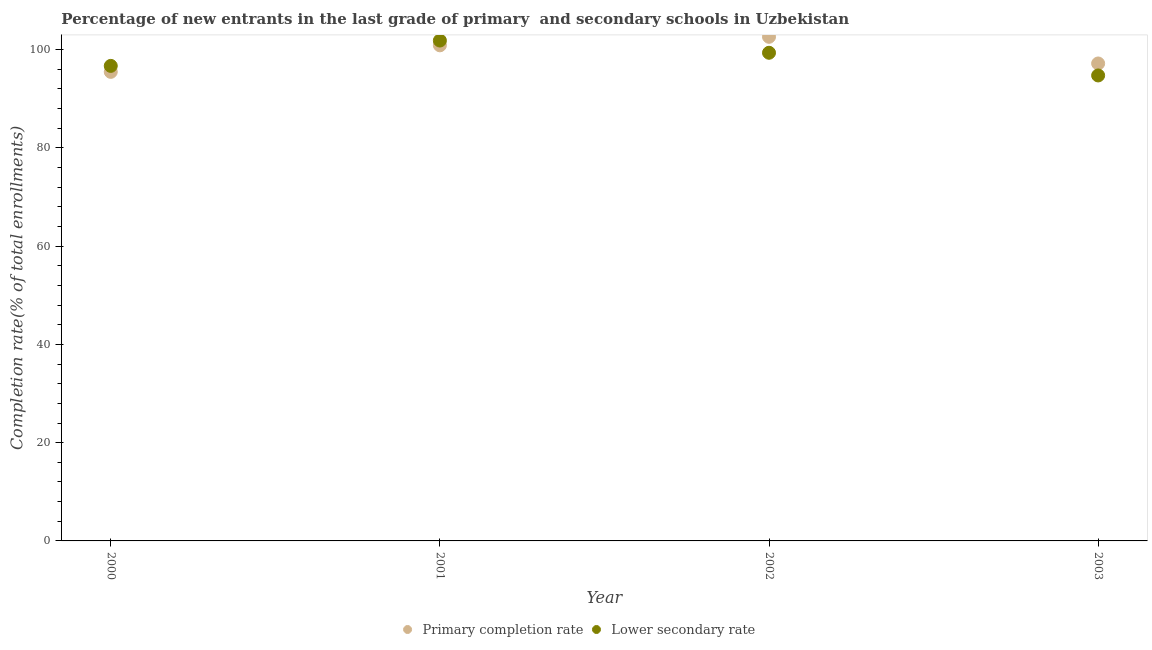What is the completion rate in primary schools in 2002?
Offer a very short reply. 102.61. Across all years, what is the maximum completion rate in secondary schools?
Ensure brevity in your answer.  101.84. Across all years, what is the minimum completion rate in secondary schools?
Provide a succinct answer. 94.74. What is the total completion rate in secondary schools in the graph?
Ensure brevity in your answer.  392.63. What is the difference between the completion rate in secondary schools in 2002 and that in 2003?
Keep it short and to the point. 4.61. What is the difference between the completion rate in secondary schools in 2003 and the completion rate in primary schools in 2001?
Keep it short and to the point. -6.13. What is the average completion rate in secondary schools per year?
Your response must be concise. 98.16. In the year 2003, what is the difference between the completion rate in secondary schools and completion rate in primary schools?
Ensure brevity in your answer.  -2.44. In how many years, is the completion rate in primary schools greater than 16 %?
Ensure brevity in your answer.  4. What is the ratio of the completion rate in secondary schools in 2001 to that in 2002?
Offer a very short reply. 1.03. What is the difference between the highest and the second highest completion rate in secondary schools?
Provide a short and direct response. 2.49. What is the difference between the highest and the lowest completion rate in secondary schools?
Ensure brevity in your answer.  7.1. In how many years, is the completion rate in primary schools greater than the average completion rate in primary schools taken over all years?
Ensure brevity in your answer.  2. Is the sum of the completion rate in primary schools in 2001 and 2003 greater than the maximum completion rate in secondary schools across all years?
Offer a very short reply. Yes. How many dotlines are there?
Your response must be concise. 2. What is the title of the graph?
Make the answer very short. Percentage of new entrants in the last grade of primary  and secondary schools in Uzbekistan. What is the label or title of the X-axis?
Your response must be concise. Year. What is the label or title of the Y-axis?
Your answer should be very brief. Completion rate(% of total enrollments). What is the Completion rate(% of total enrollments) of Primary completion rate in 2000?
Keep it short and to the point. 95.47. What is the Completion rate(% of total enrollments) of Lower secondary rate in 2000?
Offer a terse response. 96.69. What is the Completion rate(% of total enrollments) in Primary completion rate in 2001?
Your answer should be compact. 100.87. What is the Completion rate(% of total enrollments) in Lower secondary rate in 2001?
Keep it short and to the point. 101.84. What is the Completion rate(% of total enrollments) of Primary completion rate in 2002?
Provide a succinct answer. 102.61. What is the Completion rate(% of total enrollments) of Lower secondary rate in 2002?
Ensure brevity in your answer.  99.36. What is the Completion rate(% of total enrollments) of Primary completion rate in 2003?
Provide a succinct answer. 97.18. What is the Completion rate(% of total enrollments) in Lower secondary rate in 2003?
Keep it short and to the point. 94.74. Across all years, what is the maximum Completion rate(% of total enrollments) in Primary completion rate?
Provide a short and direct response. 102.61. Across all years, what is the maximum Completion rate(% of total enrollments) of Lower secondary rate?
Your answer should be very brief. 101.84. Across all years, what is the minimum Completion rate(% of total enrollments) in Primary completion rate?
Your response must be concise. 95.47. Across all years, what is the minimum Completion rate(% of total enrollments) of Lower secondary rate?
Keep it short and to the point. 94.74. What is the total Completion rate(% of total enrollments) of Primary completion rate in the graph?
Make the answer very short. 396.13. What is the total Completion rate(% of total enrollments) in Lower secondary rate in the graph?
Give a very brief answer. 392.63. What is the difference between the Completion rate(% of total enrollments) of Primary completion rate in 2000 and that in 2001?
Keep it short and to the point. -5.4. What is the difference between the Completion rate(% of total enrollments) in Lower secondary rate in 2000 and that in 2001?
Give a very brief answer. -5.16. What is the difference between the Completion rate(% of total enrollments) in Primary completion rate in 2000 and that in 2002?
Ensure brevity in your answer.  -7.14. What is the difference between the Completion rate(% of total enrollments) of Lower secondary rate in 2000 and that in 2002?
Give a very brief answer. -2.67. What is the difference between the Completion rate(% of total enrollments) of Primary completion rate in 2000 and that in 2003?
Ensure brevity in your answer.  -1.71. What is the difference between the Completion rate(% of total enrollments) of Lower secondary rate in 2000 and that in 2003?
Your response must be concise. 1.95. What is the difference between the Completion rate(% of total enrollments) in Primary completion rate in 2001 and that in 2002?
Ensure brevity in your answer.  -1.73. What is the difference between the Completion rate(% of total enrollments) of Lower secondary rate in 2001 and that in 2002?
Your answer should be very brief. 2.49. What is the difference between the Completion rate(% of total enrollments) of Primary completion rate in 2001 and that in 2003?
Ensure brevity in your answer.  3.69. What is the difference between the Completion rate(% of total enrollments) of Lower secondary rate in 2001 and that in 2003?
Your answer should be very brief. 7.1. What is the difference between the Completion rate(% of total enrollments) of Primary completion rate in 2002 and that in 2003?
Make the answer very short. 5.43. What is the difference between the Completion rate(% of total enrollments) of Lower secondary rate in 2002 and that in 2003?
Your answer should be compact. 4.61. What is the difference between the Completion rate(% of total enrollments) in Primary completion rate in 2000 and the Completion rate(% of total enrollments) in Lower secondary rate in 2001?
Ensure brevity in your answer.  -6.37. What is the difference between the Completion rate(% of total enrollments) in Primary completion rate in 2000 and the Completion rate(% of total enrollments) in Lower secondary rate in 2002?
Your answer should be compact. -3.89. What is the difference between the Completion rate(% of total enrollments) in Primary completion rate in 2000 and the Completion rate(% of total enrollments) in Lower secondary rate in 2003?
Provide a short and direct response. 0.73. What is the difference between the Completion rate(% of total enrollments) of Primary completion rate in 2001 and the Completion rate(% of total enrollments) of Lower secondary rate in 2002?
Ensure brevity in your answer.  1.52. What is the difference between the Completion rate(% of total enrollments) in Primary completion rate in 2001 and the Completion rate(% of total enrollments) in Lower secondary rate in 2003?
Provide a short and direct response. 6.13. What is the difference between the Completion rate(% of total enrollments) of Primary completion rate in 2002 and the Completion rate(% of total enrollments) of Lower secondary rate in 2003?
Offer a terse response. 7.86. What is the average Completion rate(% of total enrollments) in Primary completion rate per year?
Your response must be concise. 99.03. What is the average Completion rate(% of total enrollments) in Lower secondary rate per year?
Ensure brevity in your answer.  98.16. In the year 2000, what is the difference between the Completion rate(% of total enrollments) of Primary completion rate and Completion rate(% of total enrollments) of Lower secondary rate?
Provide a short and direct response. -1.22. In the year 2001, what is the difference between the Completion rate(% of total enrollments) in Primary completion rate and Completion rate(% of total enrollments) in Lower secondary rate?
Provide a short and direct response. -0.97. In the year 2002, what is the difference between the Completion rate(% of total enrollments) in Primary completion rate and Completion rate(% of total enrollments) in Lower secondary rate?
Make the answer very short. 3.25. In the year 2003, what is the difference between the Completion rate(% of total enrollments) of Primary completion rate and Completion rate(% of total enrollments) of Lower secondary rate?
Keep it short and to the point. 2.44. What is the ratio of the Completion rate(% of total enrollments) in Primary completion rate in 2000 to that in 2001?
Provide a short and direct response. 0.95. What is the ratio of the Completion rate(% of total enrollments) in Lower secondary rate in 2000 to that in 2001?
Keep it short and to the point. 0.95. What is the ratio of the Completion rate(% of total enrollments) in Primary completion rate in 2000 to that in 2002?
Make the answer very short. 0.93. What is the ratio of the Completion rate(% of total enrollments) in Lower secondary rate in 2000 to that in 2002?
Offer a very short reply. 0.97. What is the ratio of the Completion rate(% of total enrollments) of Primary completion rate in 2000 to that in 2003?
Your answer should be very brief. 0.98. What is the ratio of the Completion rate(% of total enrollments) in Lower secondary rate in 2000 to that in 2003?
Keep it short and to the point. 1.02. What is the ratio of the Completion rate(% of total enrollments) in Primary completion rate in 2001 to that in 2002?
Your answer should be very brief. 0.98. What is the ratio of the Completion rate(% of total enrollments) of Lower secondary rate in 2001 to that in 2002?
Your answer should be very brief. 1.02. What is the ratio of the Completion rate(% of total enrollments) of Primary completion rate in 2001 to that in 2003?
Keep it short and to the point. 1.04. What is the ratio of the Completion rate(% of total enrollments) in Lower secondary rate in 2001 to that in 2003?
Your response must be concise. 1.07. What is the ratio of the Completion rate(% of total enrollments) of Primary completion rate in 2002 to that in 2003?
Give a very brief answer. 1.06. What is the ratio of the Completion rate(% of total enrollments) in Lower secondary rate in 2002 to that in 2003?
Your answer should be compact. 1.05. What is the difference between the highest and the second highest Completion rate(% of total enrollments) of Primary completion rate?
Offer a very short reply. 1.73. What is the difference between the highest and the second highest Completion rate(% of total enrollments) of Lower secondary rate?
Offer a very short reply. 2.49. What is the difference between the highest and the lowest Completion rate(% of total enrollments) in Primary completion rate?
Provide a short and direct response. 7.14. What is the difference between the highest and the lowest Completion rate(% of total enrollments) in Lower secondary rate?
Provide a short and direct response. 7.1. 